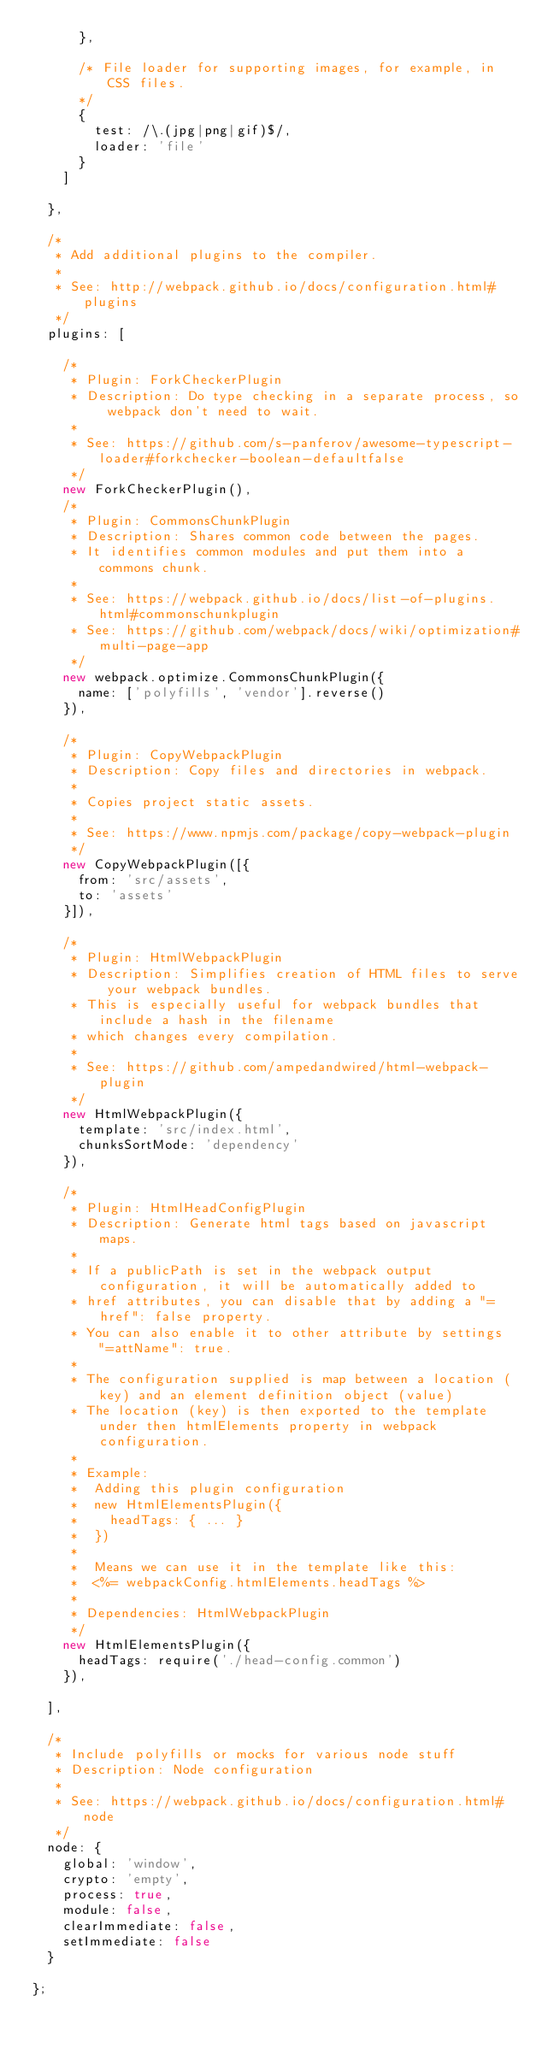<code> <loc_0><loc_0><loc_500><loc_500><_JavaScript_>      },

      /* File loader for supporting images, for example, in CSS files.
      */
      {
        test: /\.(jpg|png|gif)$/,
        loader: 'file'
      }
    ]

  },

  /*
   * Add additional plugins to the compiler.
   *
   * See: http://webpack.github.io/docs/configuration.html#plugins
   */
  plugins: [

    /*
     * Plugin: ForkCheckerPlugin
     * Description: Do type checking in a separate process, so webpack don't need to wait.
     *
     * See: https://github.com/s-panferov/awesome-typescript-loader#forkchecker-boolean-defaultfalse
     */
    new ForkCheckerPlugin(),
    /*
     * Plugin: CommonsChunkPlugin
     * Description: Shares common code between the pages.
     * It identifies common modules and put them into a commons chunk.
     *
     * See: https://webpack.github.io/docs/list-of-plugins.html#commonschunkplugin
     * See: https://github.com/webpack/docs/wiki/optimization#multi-page-app
     */
    new webpack.optimize.CommonsChunkPlugin({
      name: ['polyfills', 'vendor'].reverse()
    }),

    /*
     * Plugin: CopyWebpackPlugin
     * Description: Copy files and directories in webpack.
     *
     * Copies project static assets.
     *
     * See: https://www.npmjs.com/package/copy-webpack-plugin
     */
    new CopyWebpackPlugin([{
      from: 'src/assets',
      to: 'assets'
    }]),

    /*
     * Plugin: HtmlWebpackPlugin
     * Description: Simplifies creation of HTML files to serve your webpack bundles.
     * This is especially useful for webpack bundles that include a hash in the filename
     * which changes every compilation.
     *
     * See: https://github.com/ampedandwired/html-webpack-plugin
     */
    new HtmlWebpackPlugin({
      template: 'src/index.html',
      chunksSortMode: 'dependency'
    }),

    /*
     * Plugin: HtmlHeadConfigPlugin
     * Description: Generate html tags based on javascript maps.
     *
     * If a publicPath is set in the webpack output configuration, it will be automatically added to
     * href attributes, you can disable that by adding a "=href": false property.
     * You can also enable it to other attribute by settings "=attName": true.
     *
     * The configuration supplied is map between a location (key) and an element definition object (value)
     * The location (key) is then exported to the template under then htmlElements property in webpack configuration.
     *
     * Example:
     *  Adding this plugin configuration
     *  new HtmlElementsPlugin({
     *    headTags: { ... }
     *  })
     *
     *  Means we can use it in the template like this:
     *  <%= webpackConfig.htmlElements.headTags %>
     *
     * Dependencies: HtmlWebpackPlugin
     */
    new HtmlElementsPlugin({
      headTags: require('./head-config.common')
    }),

  ],

  /*
   * Include polyfills or mocks for various node stuff
   * Description: Node configuration
   *
   * See: https://webpack.github.io/docs/configuration.html#node
   */
  node: {
    global: 'window',
    crypto: 'empty',
    process: true,
    module: false,
    clearImmediate: false,
    setImmediate: false
  }

};
</code> 